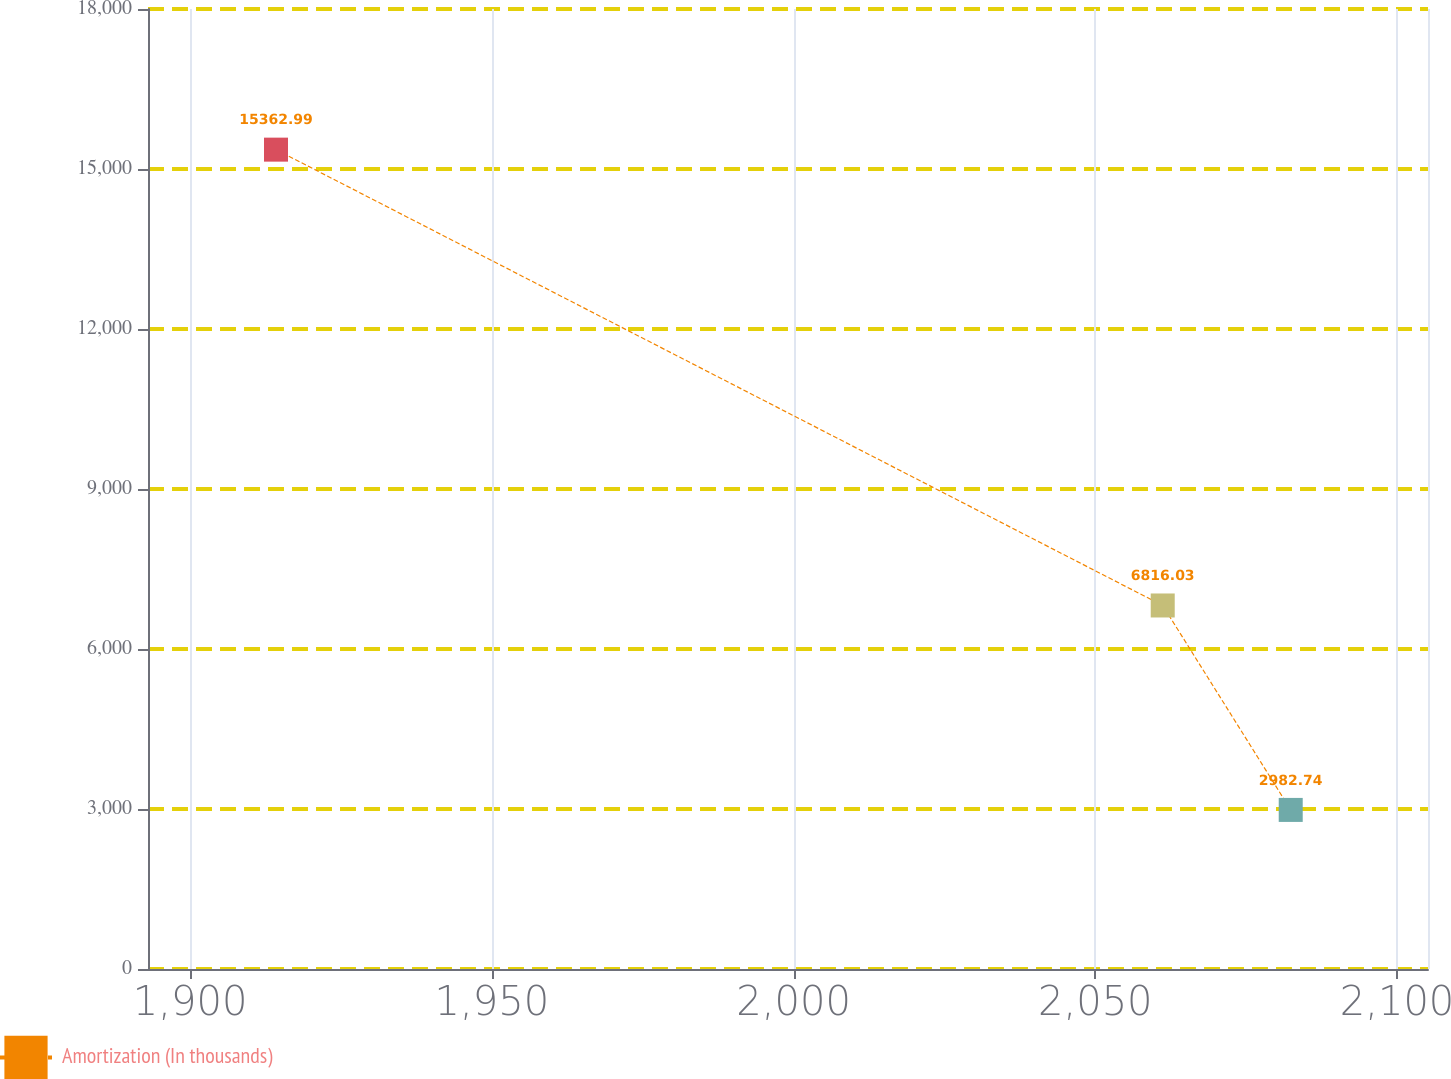<chart> <loc_0><loc_0><loc_500><loc_500><line_chart><ecel><fcel>Amortization (In thousands)<nl><fcel>1914.23<fcel>15363<nl><fcel>2061.17<fcel>6816.03<nl><fcel>2082.38<fcel>2982.74<nl><fcel>2126.34<fcel>1607.16<nl></chart> 